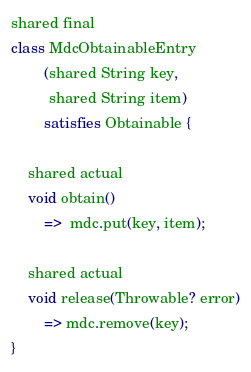Convert code to text. <code><loc_0><loc_0><loc_500><loc_500><_Ceylon_>shared final
class MdcObtainableEntry
        (shared String key,
         shared String item)
        satisfies Obtainable {

    shared actual
    void obtain()
        =>  mdc.put(key, item);

    shared actual
    void release(Throwable? error)
        => mdc.remove(key);
}
</code> 